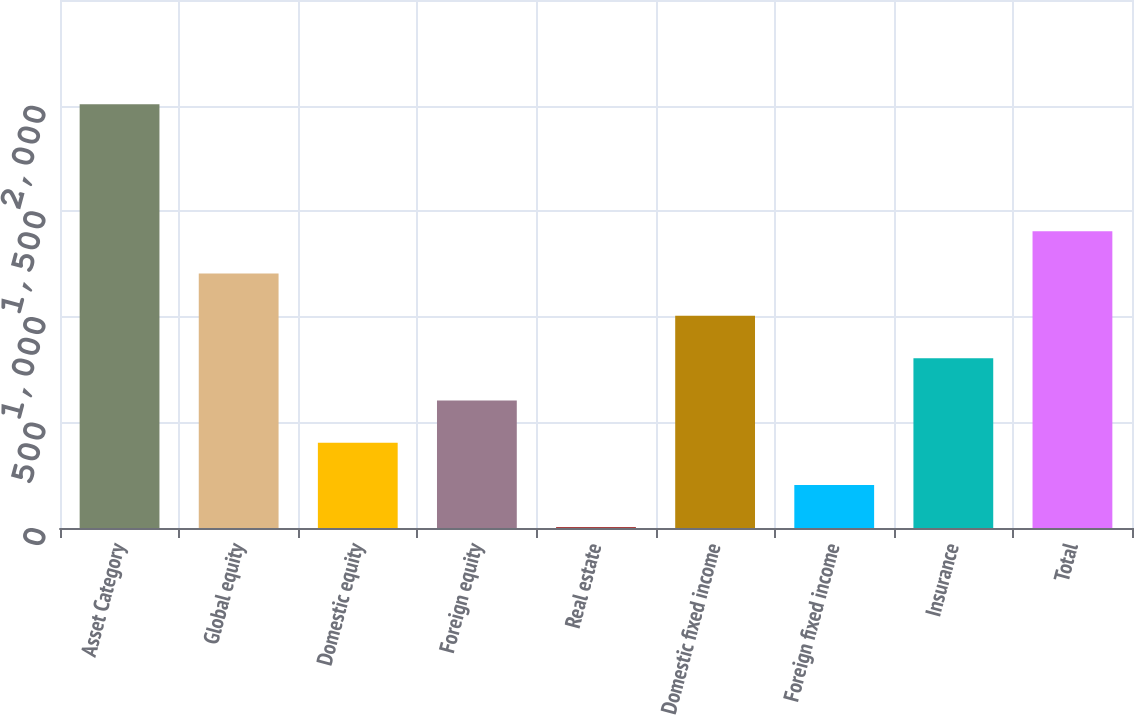Convert chart to OTSL. <chart><loc_0><loc_0><loc_500><loc_500><bar_chart><fcel>Asset Category<fcel>Global equity<fcel>Domestic equity<fcel>Foreign equity<fcel>Real estate<fcel>Domestic fixed income<fcel>Foreign fixed income<fcel>Insurance<fcel>Total<nl><fcel>2006<fcel>1204.8<fcel>403.6<fcel>603.9<fcel>3<fcel>1004.5<fcel>203.3<fcel>804.2<fcel>1405.1<nl></chart> 